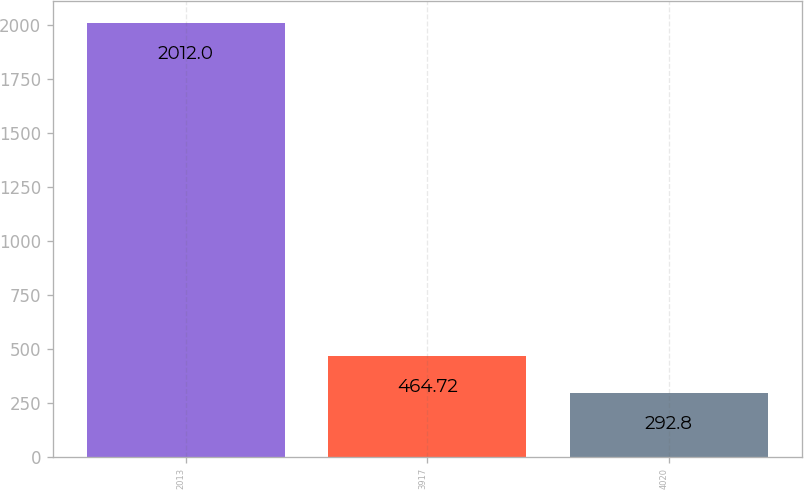Convert chart to OTSL. <chart><loc_0><loc_0><loc_500><loc_500><bar_chart><fcel>2013<fcel>3917<fcel>4020<nl><fcel>2012<fcel>464.72<fcel>292.8<nl></chart> 